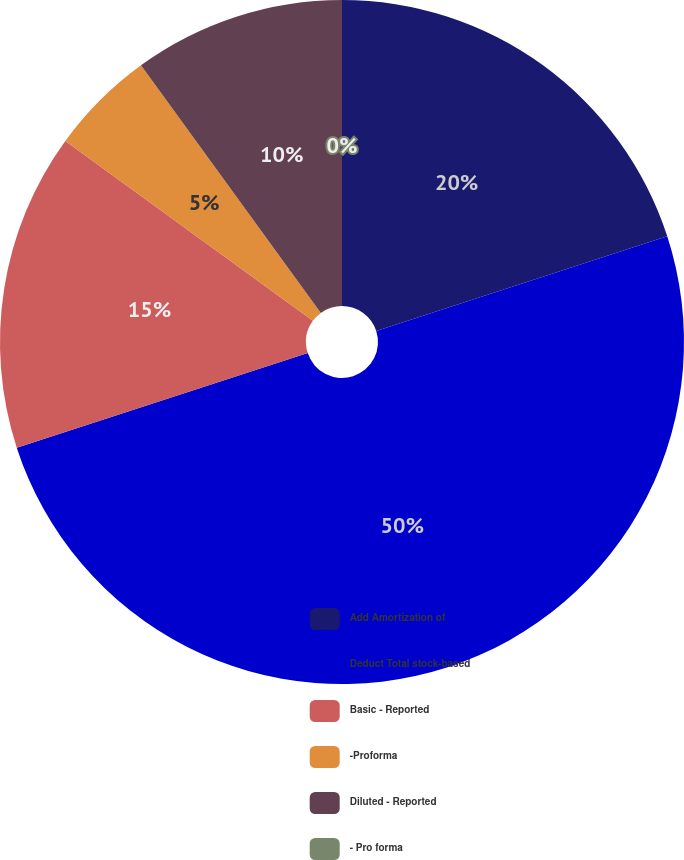Convert chart. <chart><loc_0><loc_0><loc_500><loc_500><pie_chart><fcel>Add Amortization of<fcel>Deduct Total stock-based<fcel>Basic - Reported<fcel>-Proforma<fcel>Diluted - Reported<fcel>- Pro forma<nl><fcel>20.0%<fcel>50.0%<fcel>15.0%<fcel>5.0%<fcel>10.0%<fcel>0.0%<nl></chart> 